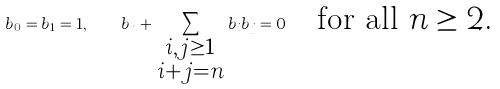Convert formula to latex. <formula><loc_0><loc_0><loc_500><loc_500>b _ { 0 } = b _ { 1 } = 1 , \quad b _ { n } + \sum _ { \begin{smallmatrix} i , j \geq 1 \\ i + j = n \end{smallmatrix} } b _ { i } b _ { j } = 0 \quad \text {for all $n\geq 2$.}</formula> 